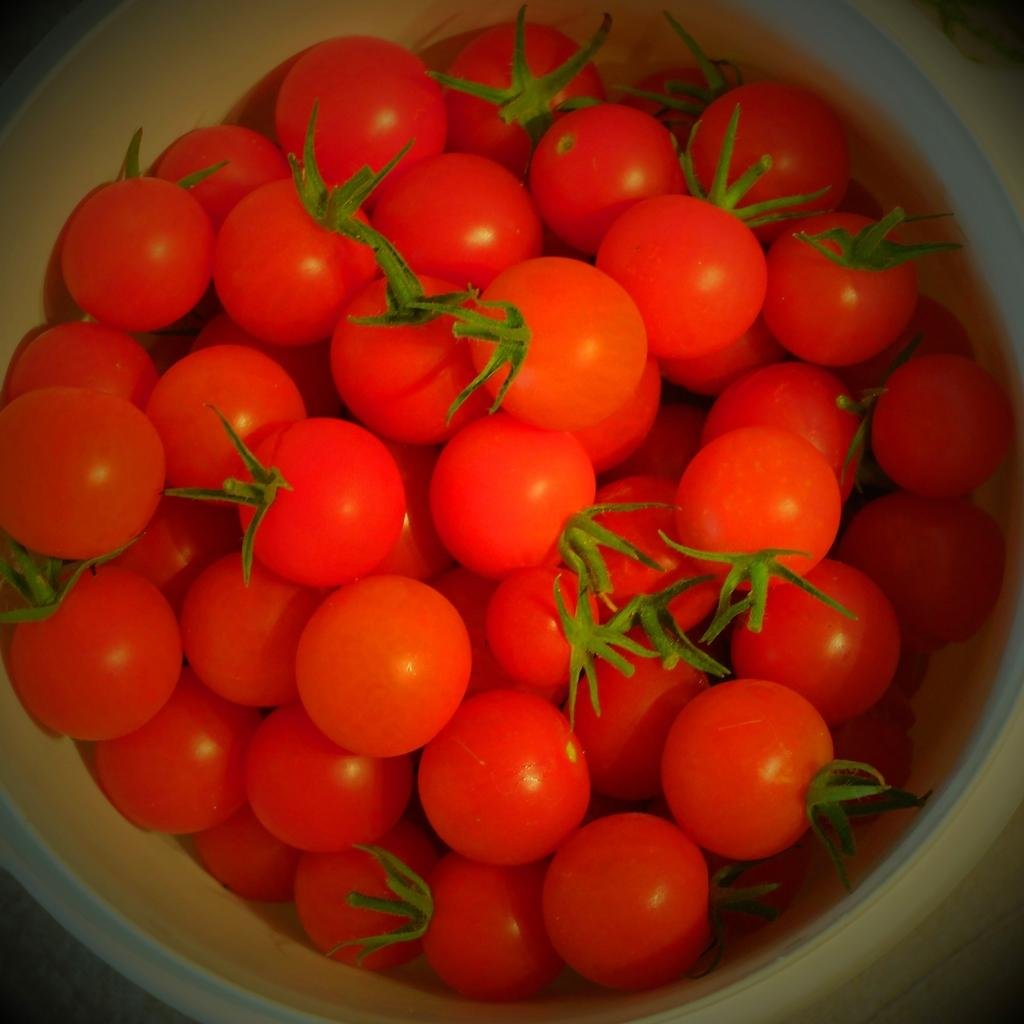What type of food can be seen in the image? There are vegetables in the image. Can you identify the specific type of vegetable? The vegetables appear to be tomatoes. How are the tomatoes arranged in the image? The tomatoes are placed in a bowl. What color is the toe on the tomato in the image? There is no toe present on the tomatoes in the image, as tomatoes are a type of fruit and do not have toes. 